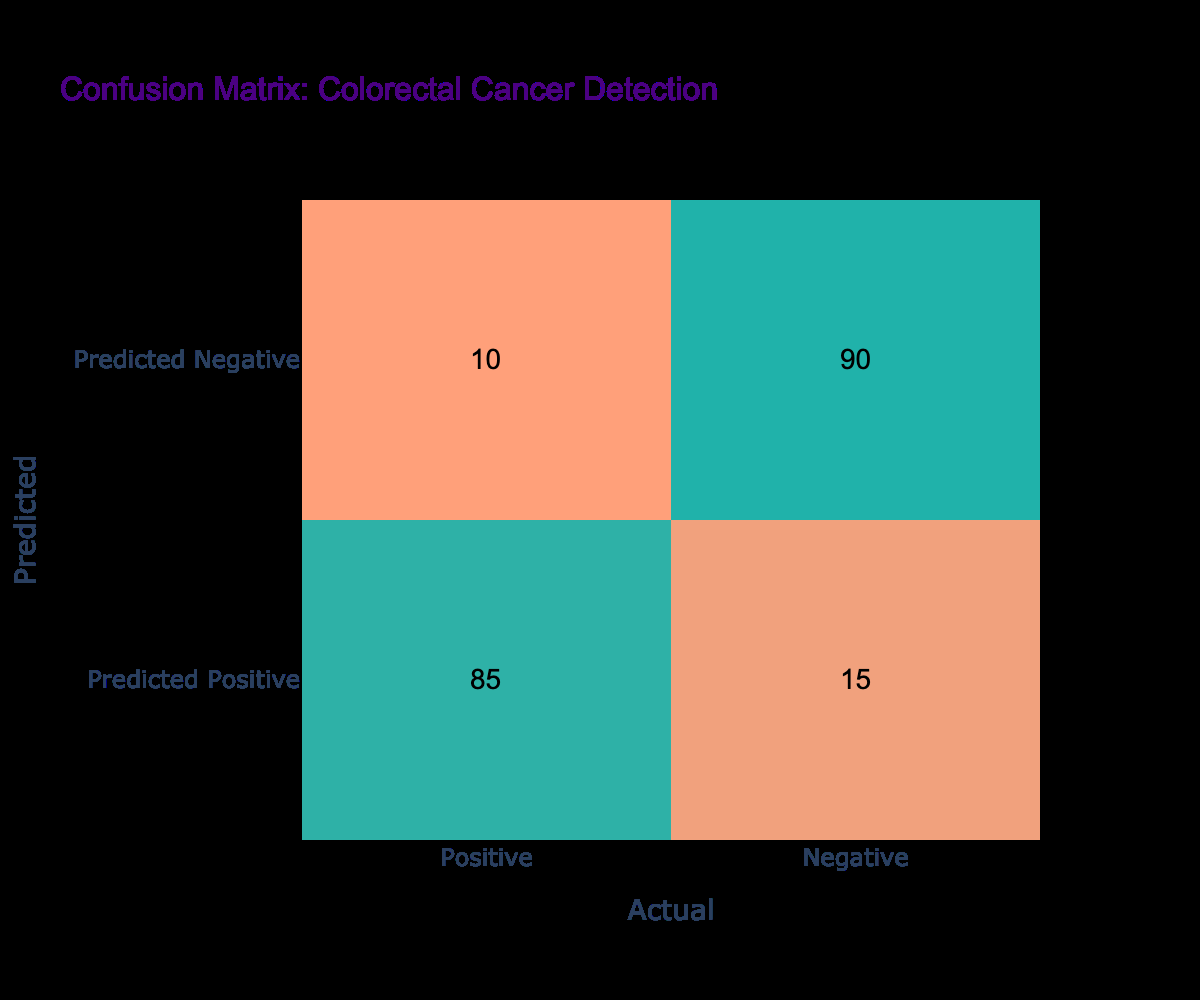What is the total number of actual positive cases? The table shows that there are 85 predicted positive cases and 10 predicted negative cases. In the context of the actual positives, we should only consider the positive column (the first column), which has a total of 85 cases. Therefore, the total actual positive cases is simply the number from that column.
Answer: 85 How many predicted negative cases were actually positive? From the table, under the "Predicted Negative" row, there are 10 cases marked as actually positive. This is directly seen in the matrix.
Answer: 10 What is the ratio of true positives to false positives? True positives are the cases where patients were correctly identified as having colorectal cancer, which is 85. False positives are the cases that were incorrectly identified as having colorectal cancer, which are 15. The ratio of true positives to false positives can be calculated as 85/15 = 5.67.
Answer: 5.67 Is the number of true negatives greater than the number of false negatives? True negatives are the cases that were correctly identified as not having colorectal cancer, which is 90. False negatives are the cases actually positive but predicted negative, which are 10. Since 90 is greater than 10, the answer is true.
Answer: Yes What percentage of predicted positive cases were true positives? The total number of predicted positive cases is the sum of the cases in the predicted positive row, 85 (true positives) + 15 (false positives) = 100. The percentage of predicted positive cases that were true positives is (85/100) * 100 = 85%. The answer is simply derived from the percentage calculation based on the counts from the matrix.
Answer: 85% What is the total number of cases predicted negative? The total number of cases predicted negative can be obtained by heading to the "Predicted Negative" row of the matrix, which sums up 10 (false negatives) and 90 (true negatives) to yield a total of 100 cases.
Answer: 100 How many cases were correctly identified as not having colorectal cancer? This value is represented in the table under the "Predicted Negative" row and the "Negative" column, which is equal to 90 cases. This indicates the true negatives, meaning these are cases that did not have cancer and were correctly identified as such.
Answer: 90 What is the total number of cases with colorectal cancer detected? The total number of cases with colorectal cancer detected comprises true positives (85) and false negatives (10), resulting in 85 + 10 = 95. This total represents all actual positive cases, showing that 95 cases of colorectal cancer were involved.
Answer: 95 What is the difference between the true positive cases and the true negative cases? True positives are 85 and true negatives are 90. The difference is calculated as 90 (true negatives) - 85 (true positives) = 5. This shows the variance between the two classifications.
Answer: 5 